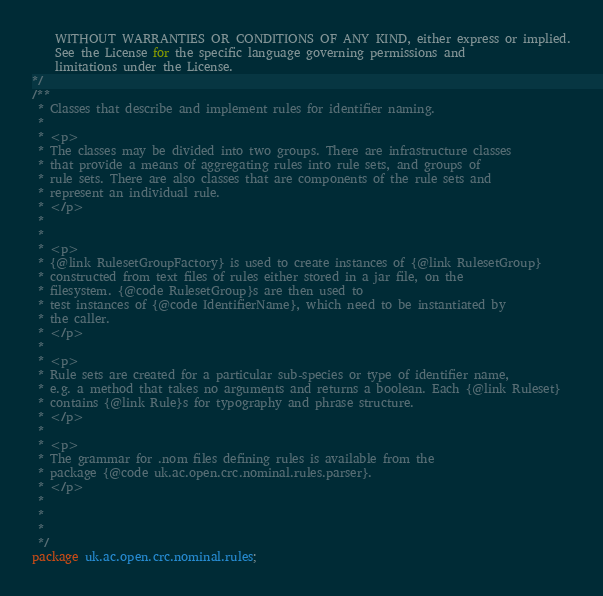<code> <loc_0><loc_0><loc_500><loc_500><_Java_>    WITHOUT WARRANTIES OR CONDITIONS OF ANY KIND, either express or implied.
    See the License for the specific language governing permissions and
    limitations under the License.
*/
/**
 * Classes that describe and implement rules for identifier naming.
 * 
 * <p>
 * The classes may be divided into two groups. There are infrastructure classes
 * that provide a means of aggregating rules into rule sets, and groups of 
 * rule sets. There are also classes that are components of the rule sets and 
 * represent an individual rule. 
 * </p>
 * 
 * 
 * <p>
 * {@link RulesetGroupFactory} is used to create instances of {@link RulesetGroup}
 * constructed from text files of rules either stored in a jar file, on the 
 * filesystem. {@code RulesetGroup}s are then used to 
 * test instances of {@code IdentifierName}, which need to be instantiated by 
 * the caller. 
 * </p>
 * 
 * <p>
 * Rule sets are created for a particular sub-species or type of identifier name, 
 * e.g. a method that takes no arguments and returns a boolean. Each {@link Ruleset} 
 * contains {@link Rule}s for typography and phrase structure. 
 * </p>
 * 
 * <p>
 * The grammar for .nom files defining rules is available from the 
 * package {@code uk.ac.open.crc.nominal.rules.parser}.
 * </p>
 * 
 * 
 * 
 */
package uk.ac.open.crc.nominal.rules;
</code> 